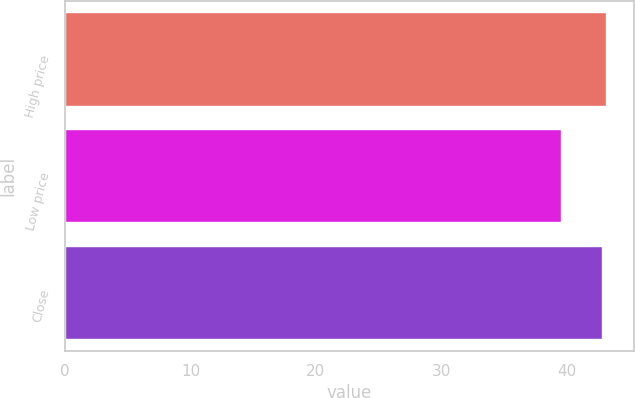Convert chart. <chart><loc_0><loc_0><loc_500><loc_500><bar_chart><fcel>High price<fcel>Low price<fcel>Close<nl><fcel>43.18<fcel>39.53<fcel>42.84<nl></chart> 